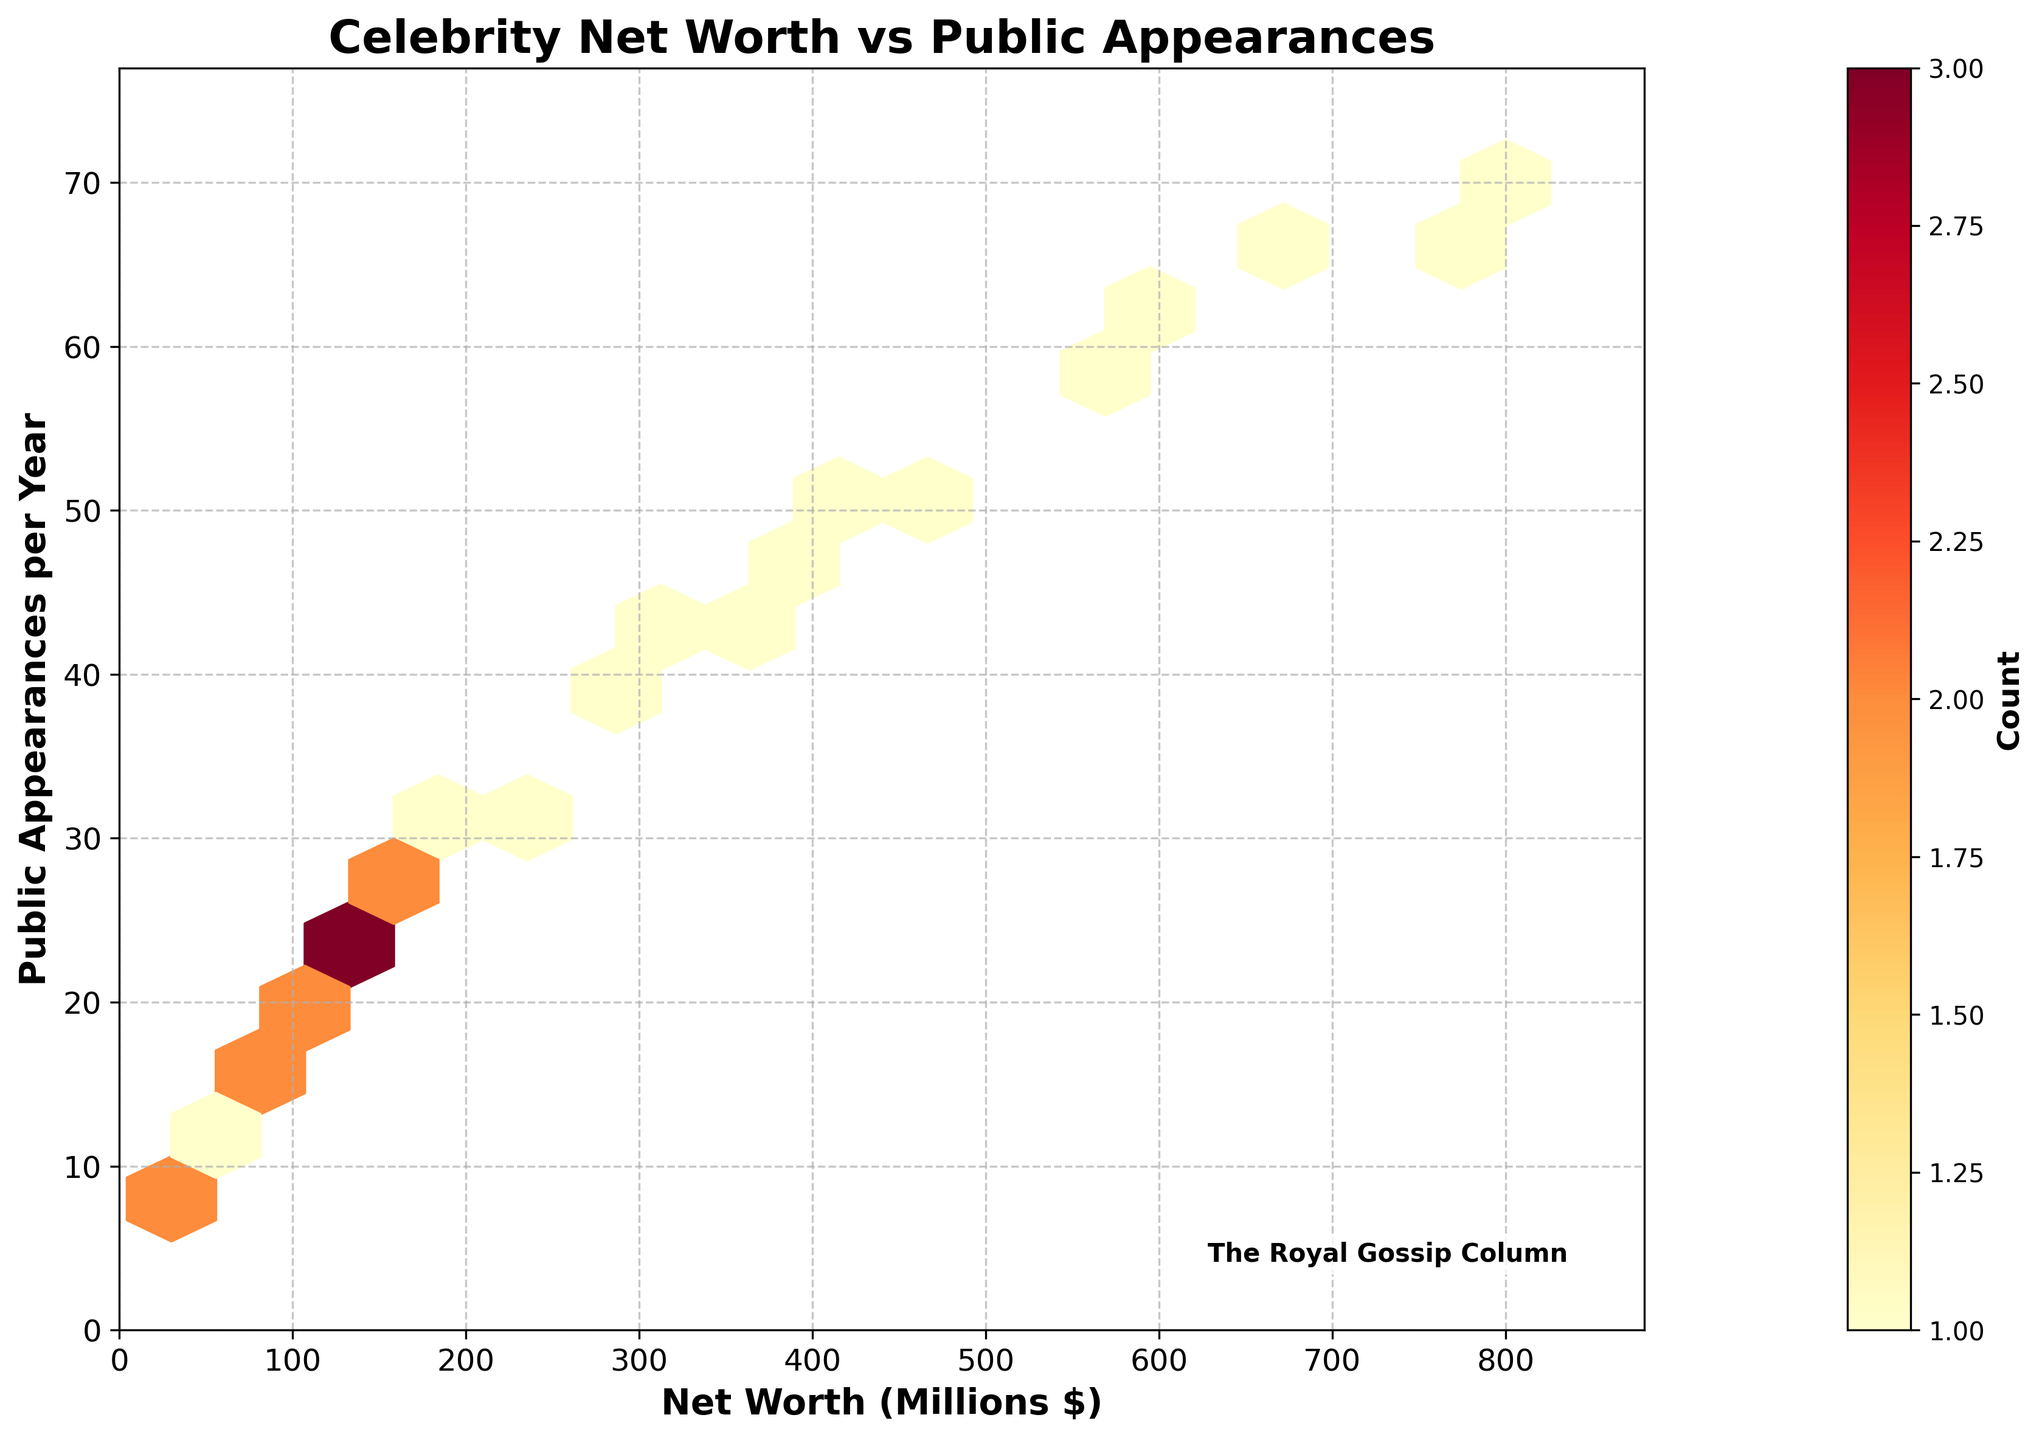What is the title of the hexbin plot? The title of the hexbin plot can be found at the top of the plot, it reads "Celebrity Net Worth vs Public Appearances".
Answer: Celebrity Net Worth vs Public Appearances What does the color bar represent? The color bar on the right side of the hexbin plot represents the count of data points within each hexbin. It is labeled with "Count".
Answer: Count What are the x-axis and y-axis labels? The x-axis label is "Net Worth (Millions $)", and the y-axis label is "Public Appearances per Year". These labels can be found directly below and to the left of the plot, respectively.
Answer: Net Worth (Millions $) and Public Appearances per Year What is the range displayed on the x-axis? The x-axis range can be derived by looking at the minimum and maximum values on the axis. It spans from 0 to approximately 880 millions of dollars.
Answer: 0 to 880 Which range of net worth has the highest frequency of public appearances? By examining the hexbin plot, the area with the densest color indicates the highest count. The range with the highest frequency appears to be between 300 and 400 million dollars.
Answer: 300 to 400 million dollars What is the most frequent range of public appearances per year? By looking at the areas of the plot with the most intense hexbin coloring, it indicates the highest frequency. The most frequent range is between 20 and 30 appearances per year.
Answer: 20 to 30 appearances per year Are there more public appearances associated with higher net worth? By observing the general trend in the plot, as net worth increases, the number of public appearances also increases, indicating a positive correlation.
Answer: Yes Which data point corresponds to the highest net worth and how many public appearances does it have? The data point with the highest net worth corresponds to 800 million dollars, and it has 70 public appearances per year. This can be found by locating the furthest right point on the x-axis.
Answer: 800 million dollars and 70 appearances In which net worth and public appearances range does the plot show the least density of data points? The least dense area can be found by identifying the areas in the hexbin plot with the lightest or no color. This occurs in the range of 0 to 50 million dollars for net worth and 0 to 10 public appearances per year.
Answer: 0 to 50 million dollars and 0 to 10 appearances 